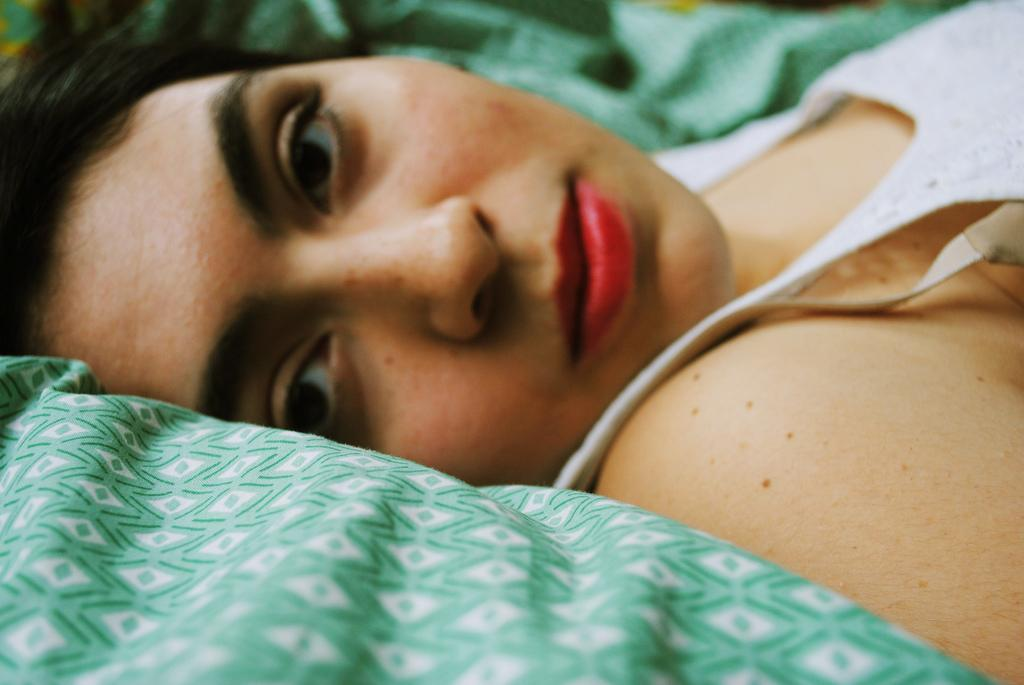Who is present in the image? There is a woman in the image. What is the woman doing in the image? The woman is lying on a cloth. What type of apple is the woman eating in the image? There is no apple present in the image, and the woman is not eating anything. 